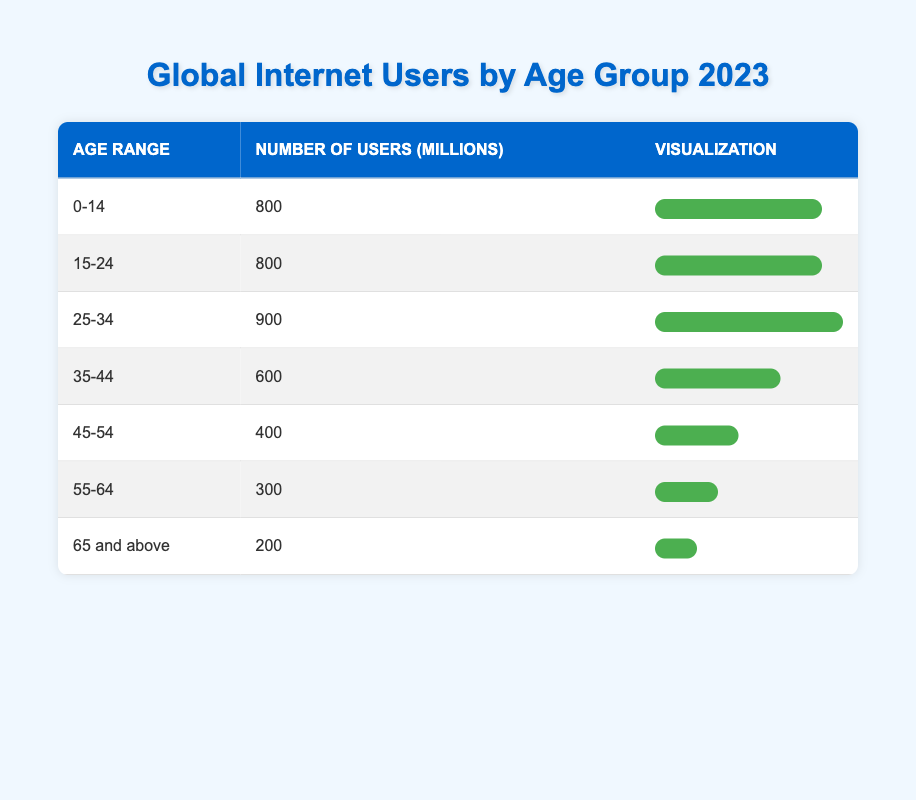What is the number of global internet users aged 25-34 in millions? The table shows a specific row for the age range "25-34" where the number of users is explicitly listed as 900 million.
Answer: 900 million Which age group has the highest number of internet users? By examining the table, the age groups "0-14" and "15-24" both have 800 million users, but the "25-34" group has the highest with 900 million.
Answer: 25-34 What is the total number of internet users for all age groups combined in millions? To find the total, add the number of users across all age groups: 800 + 800 + 900 + 600 + 400 + 300 + 200 = 4000 million.
Answer: 4000 million Is the number of internet users in the age group 55-64 greater than that of the group 45-54? The table shows that the "55-64" age group has 300 million users, which is greater than the "45-54" group with 400 million users. Therefore, the statement is false.
Answer: No What percentage of the total internet users do the 65 and above age group represent? The total is 4000 million. The group "65 and above" has 200 million users. To find the percentage, calculate (200/4000) * 100 = 5%.
Answer: 5% What is the difference in the number of users between the 35-44 and the 25-34 age groups? The "35-44" group has 600 million users, and the "25-34" group has 900 million users. Calculate the difference: 900 - 600 = 300 million.
Answer: 300 million If we group together the users from the age ranges 15-24 and 35-44, what would their combined total be? The "15-24" group has 800 million users and the "35-44" has 600 million users. Adding these gives 800 + 600 = 1400 million.
Answer: 1400 million What can be inferred about internet usage trends for older age groups based on this table? Observing the values, it's clear that the number of internet users decreases with age; the "65 and above" group has the least users at 200 million, indicating lower internet usage among older populations.
Answer: Decreasing trend with age 